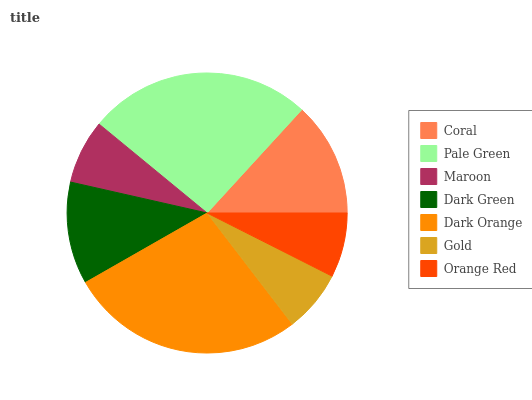Is Gold the minimum?
Answer yes or no. Yes. Is Dark Orange the maximum?
Answer yes or no. Yes. Is Pale Green the minimum?
Answer yes or no. No. Is Pale Green the maximum?
Answer yes or no. No. Is Pale Green greater than Coral?
Answer yes or no. Yes. Is Coral less than Pale Green?
Answer yes or no. Yes. Is Coral greater than Pale Green?
Answer yes or no. No. Is Pale Green less than Coral?
Answer yes or no. No. Is Dark Green the high median?
Answer yes or no. Yes. Is Dark Green the low median?
Answer yes or no. Yes. Is Pale Green the high median?
Answer yes or no. No. Is Orange Red the low median?
Answer yes or no. No. 